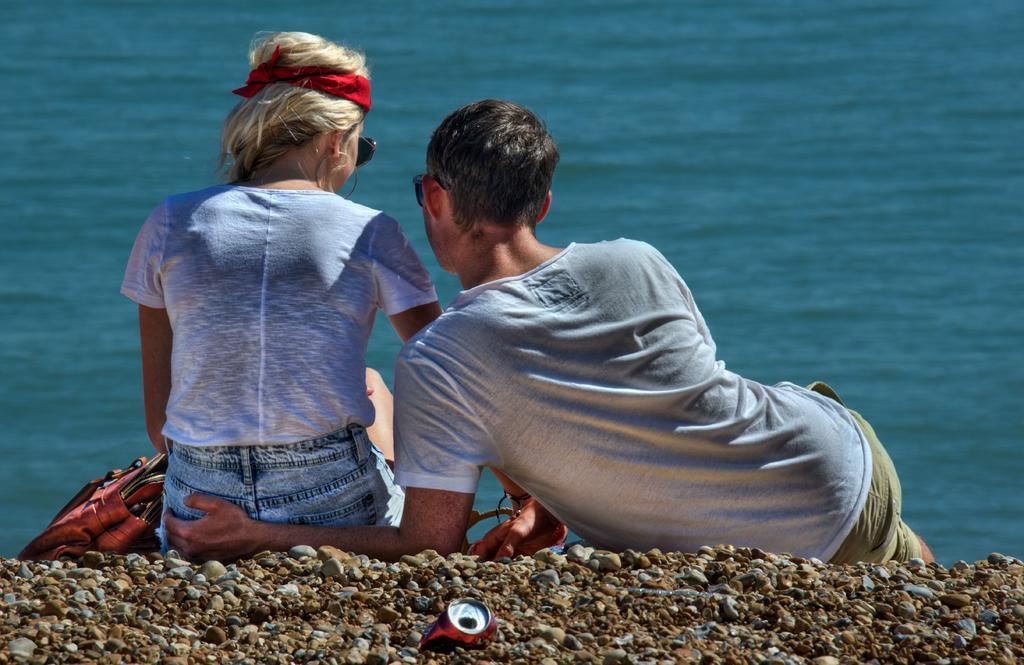Please provide a concise description of this image. In this image we can see two people sitting on the surface near to the lake, one handbag on the surface, one lake and some stones are there. 